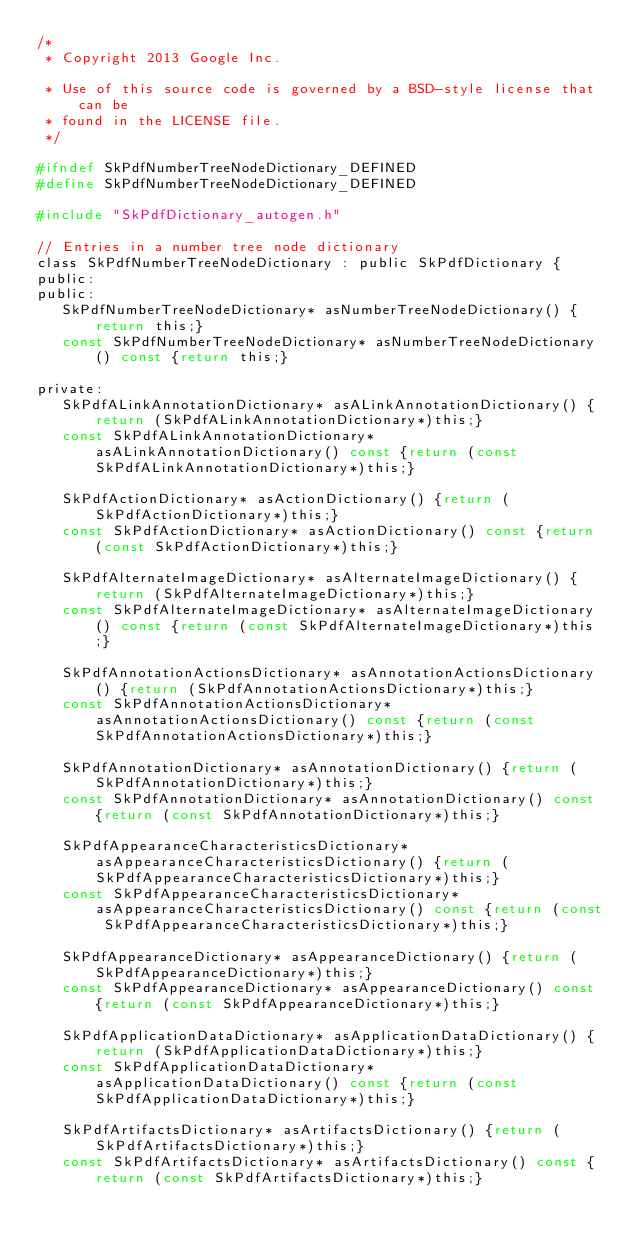Convert code to text. <code><loc_0><loc_0><loc_500><loc_500><_C_>/*
 * Copyright 2013 Google Inc.

 * Use of this source code is governed by a BSD-style license that can be
 * found in the LICENSE file.
 */

#ifndef SkPdfNumberTreeNodeDictionary_DEFINED
#define SkPdfNumberTreeNodeDictionary_DEFINED

#include "SkPdfDictionary_autogen.h"

// Entries in a number tree node dictionary
class SkPdfNumberTreeNodeDictionary : public SkPdfDictionary {
public:
public:
   SkPdfNumberTreeNodeDictionary* asNumberTreeNodeDictionary() {return this;}
   const SkPdfNumberTreeNodeDictionary* asNumberTreeNodeDictionary() const {return this;}

private:
   SkPdfALinkAnnotationDictionary* asALinkAnnotationDictionary() {return (SkPdfALinkAnnotationDictionary*)this;}
   const SkPdfALinkAnnotationDictionary* asALinkAnnotationDictionary() const {return (const SkPdfALinkAnnotationDictionary*)this;}

   SkPdfActionDictionary* asActionDictionary() {return (SkPdfActionDictionary*)this;}
   const SkPdfActionDictionary* asActionDictionary() const {return (const SkPdfActionDictionary*)this;}

   SkPdfAlternateImageDictionary* asAlternateImageDictionary() {return (SkPdfAlternateImageDictionary*)this;}
   const SkPdfAlternateImageDictionary* asAlternateImageDictionary() const {return (const SkPdfAlternateImageDictionary*)this;}

   SkPdfAnnotationActionsDictionary* asAnnotationActionsDictionary() {return (SkPdfAnnotationActionsDictionary*)this;}
   const SkPdfAnnotationActionsDictionary* asAnnotationActionsDictionary() const {return (const SkPdfAnnotationActionsDictionary*)this;}

   SkPdfAnnotationDictionary* asAnnotationDictionary() {return (SkPdfAnnotationDictionary*)this;}
   const SkPdfAnnotationDictionary* asAnnotationDictionary() const {return (const SkPdfAnnotationDictionary*)this;}

   SkPdfAppearanceCharacteristicsDictionary* asAppearanceCharacteristicsDictionary() {return (SkPdfAppearanceCharacteristicsDictionary*)this;}
   const SkPdfAppearanceCharacteristicsDictionary* asAppearanceCharacteristicsDictionary() const {return (const SkPdfAppearanceCharacteristicsDictionary*)this;}

   SkPdfAppearanceDictionary* asAppearanceDictionary() {return (SkPdfAppearanceDictionary*)this;}
   const SkPdfAppearanceDictionary* asAppearanceDictionary() const {return (const SkPdfAppearanceDictionary*)this;}

   SkPdfApplicationDataDictionary* asApplicationDataDictionary() {return (SkPdfApplicationDataDictionary*)this;}
   const SkPdfApplicationDataDictionary* asApplicationDataDictionary() const {return (const SkPdfApplicationDataDictionary*)this;}

   SkPdfArtifactsDictionary* asArtifactsDictionary() {return (SkPdfArtifactsDictionary*)this;}
   const SkPdfArtifactsDictionary* asArtifactsDictionary() const {return (const SkPdfArtifactsDictionary*)this;}
</code> 